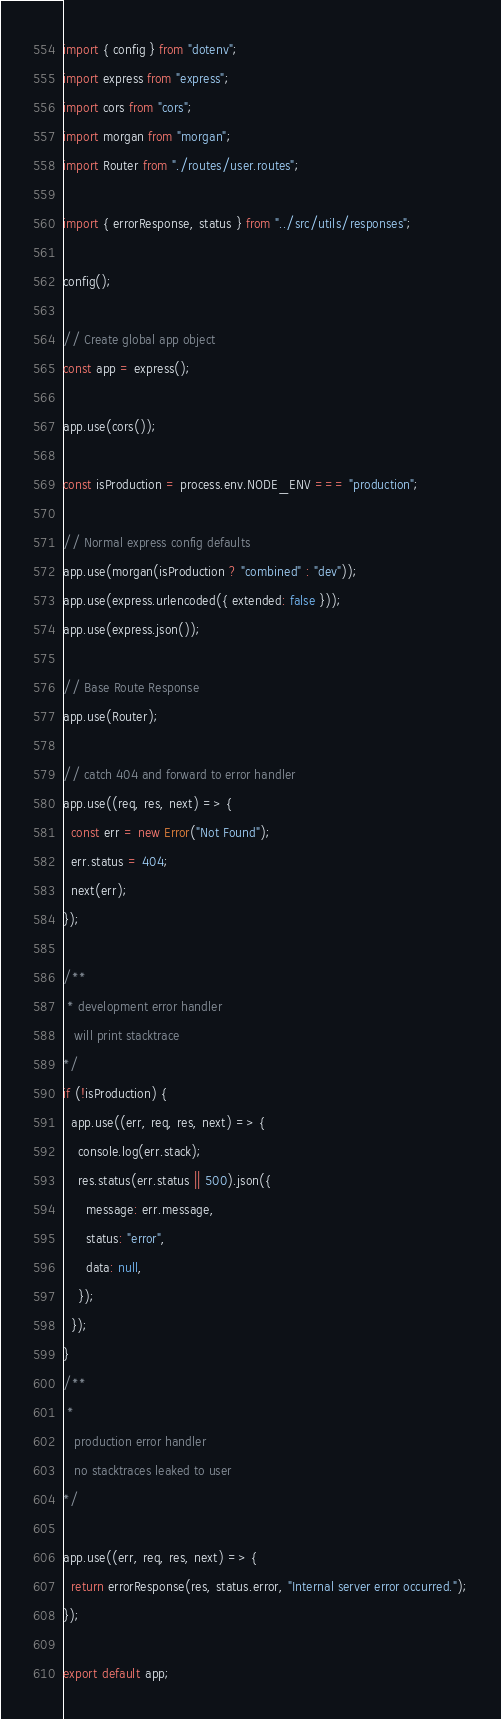<code> <loc_0><loc_0><loc_500><loc_500><_JavaScript_>import { config } from "dotenv";
import express from "express";
import cors from "cors";
import morgan from "morgan";
import Router from "./routes/user.routes";

import { errorResponse, status } from "../src/utils/responses";

config();

// Create global app object
const app = express();

app.use(cors());

const isProduction = process.env.NODE_ENV === "production";

// Normal express config defaults
app.use(morgan(isProduction ? "combined" : "dev"));
app.use(express.urlencoded({ extended: false }));
app.use(express.json());

// Base Route Response
app.use(Router);

// catch 404 and forward to error handler
app.use((req, res, next) => {
  const err = new Error("Not Found");
  err.status = 404;
  next(err);
});

/**
 * development error handler
   will print stacktrace
*/
if (!isProduction) {
  app.use((err, req, res, next) => {
    console.log(err.stack);
    res.status(err.status || 500).json({
      message: err.message,
      status: "error",
      data: null,
    });
  });
}
/**
 *
   production error handler
   no stacktraces leaked to user
*/

app.use((err, req, res, next) => {
  return errorResponse(res, status.error, "Internal server error occurred.");
});

export default app;
</code> 